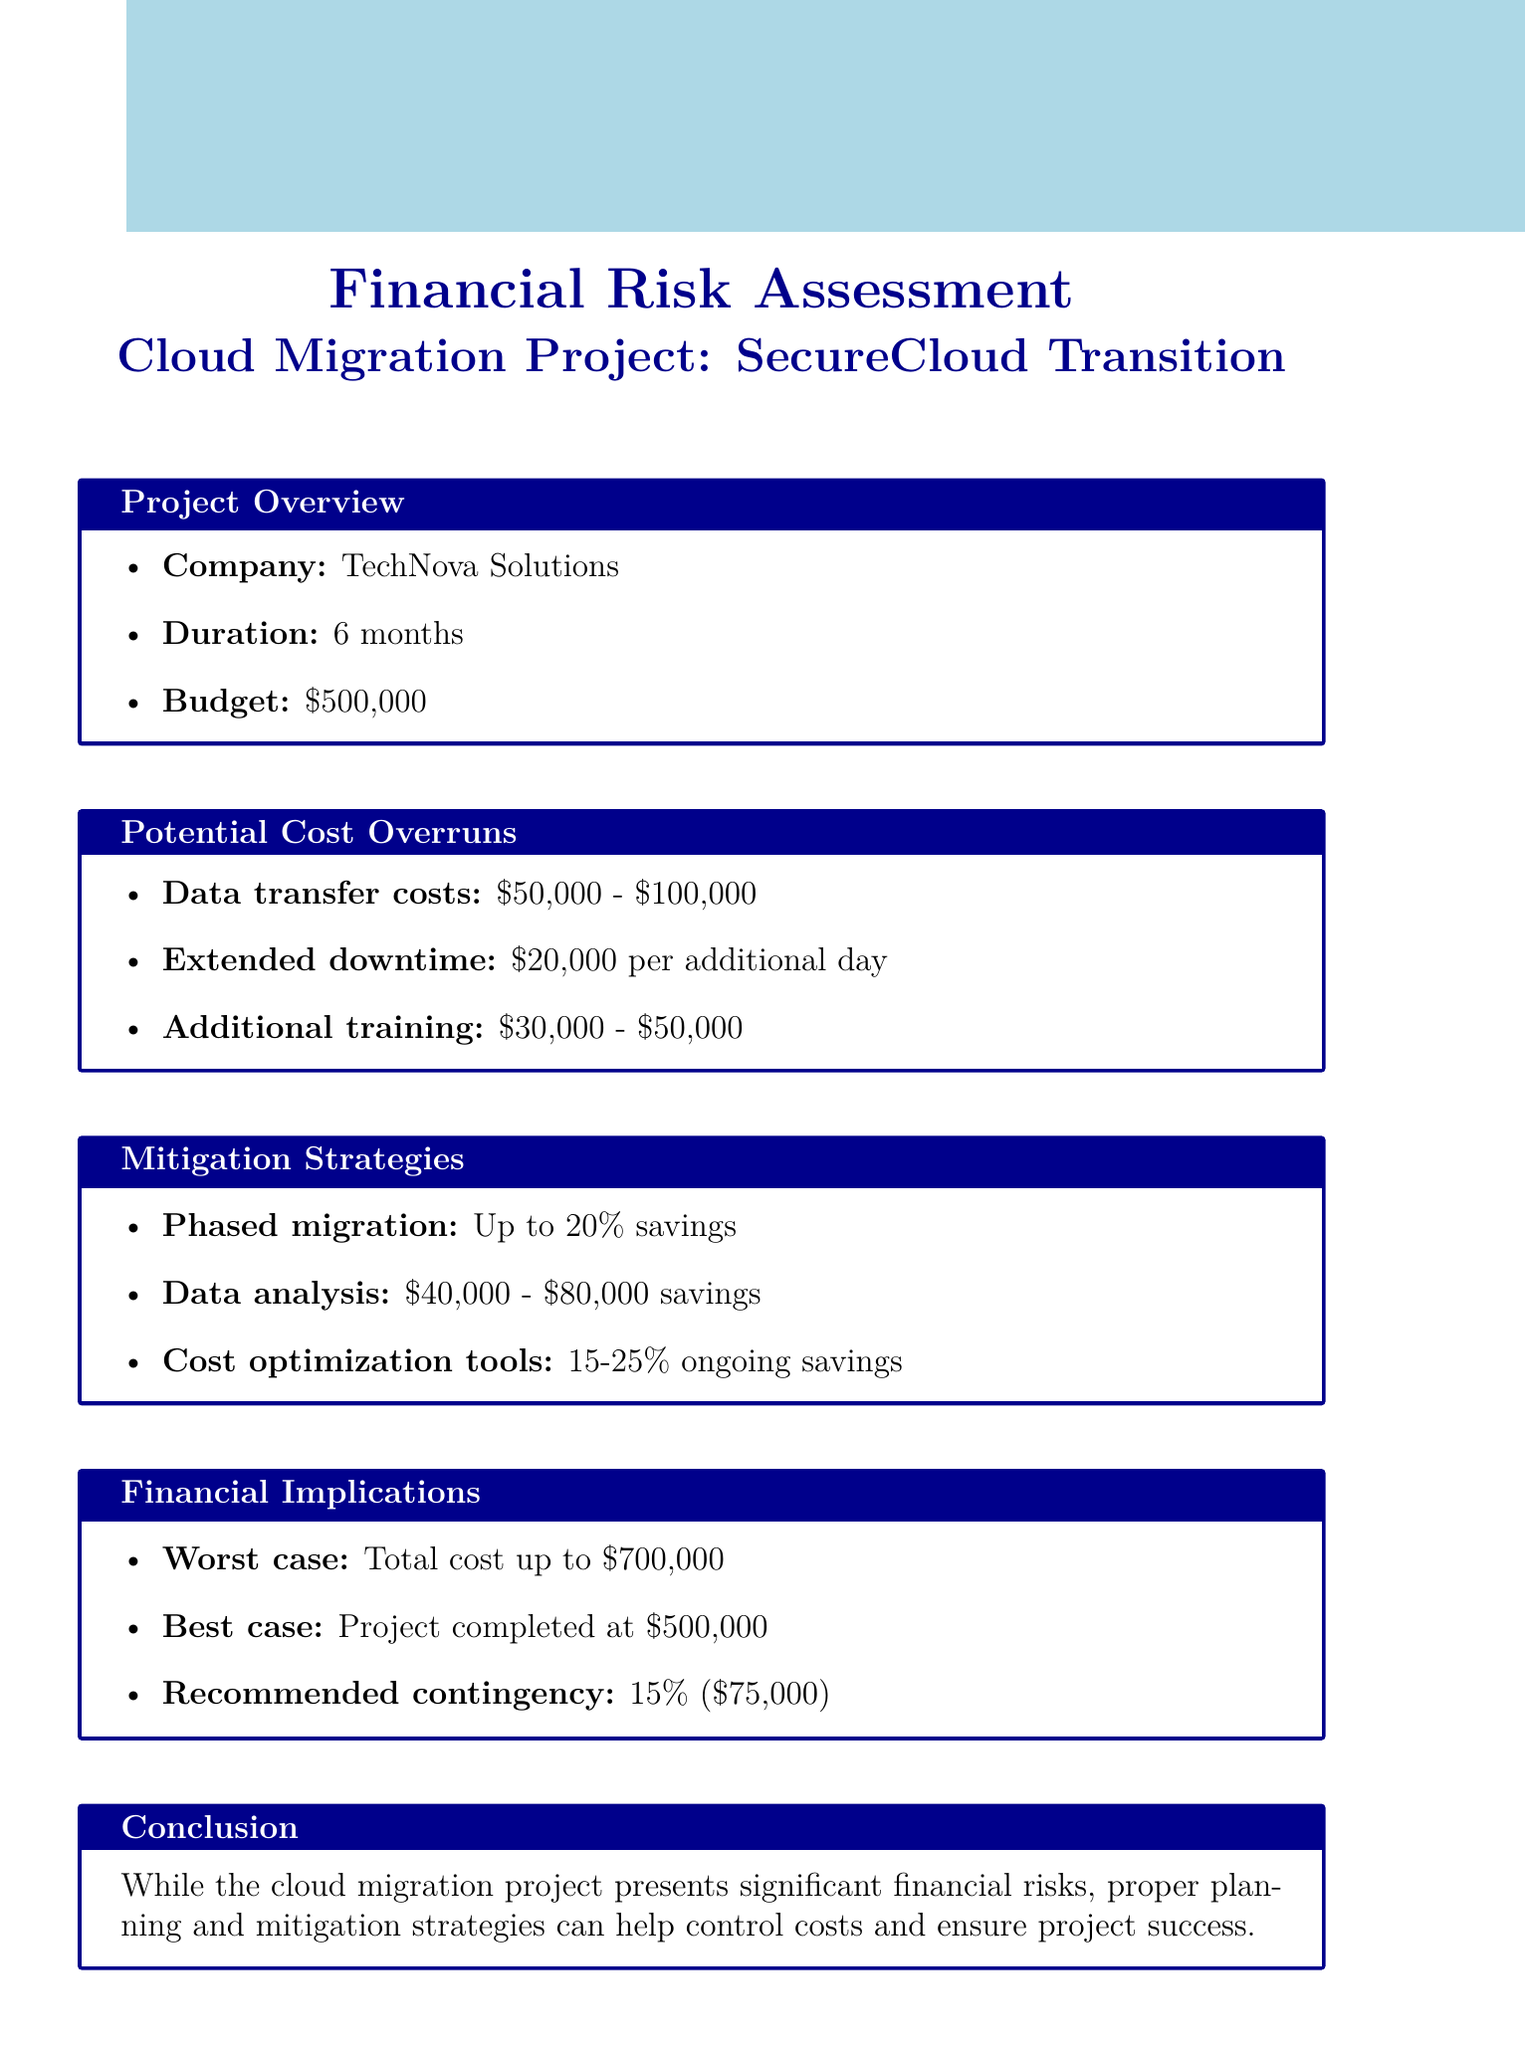what is the project name? The project name is listed in the document under project overview.
Answer: SecureCloud Transition who is the company managing the project? The name of the company is provided in the project overview section.
Answer: TechNova Solutions what is the estimated budget for the project? The estimated budget is specified in the project overview section.
Answer: $500,000 what is the potential impact of extended downtime? This cost is mentioned in the potential cost overruns section.
Answer: $20,000 per day of additional downtime what is the worst-case scenario total cost? The worst-case scenario total cost is specified in the financial implications section.
Answer: $700,000 what mitigation strategy could save up to 20% of total project cost? This strategy is listed in the mitigation strategies section.
Answer: Phased migration approach how much is the recommended contingency budget? The recommended contingency budget is noted in the financial implications section.
Answer: $75,000 what is one tool suggested for cost optimization? This tool is mentioned in the mitigation strategies section.
Answer: AWS Cost Explorer what is the duration of the cloud migration project? The duration is provided in the project overview section.
Answer: 6 months 